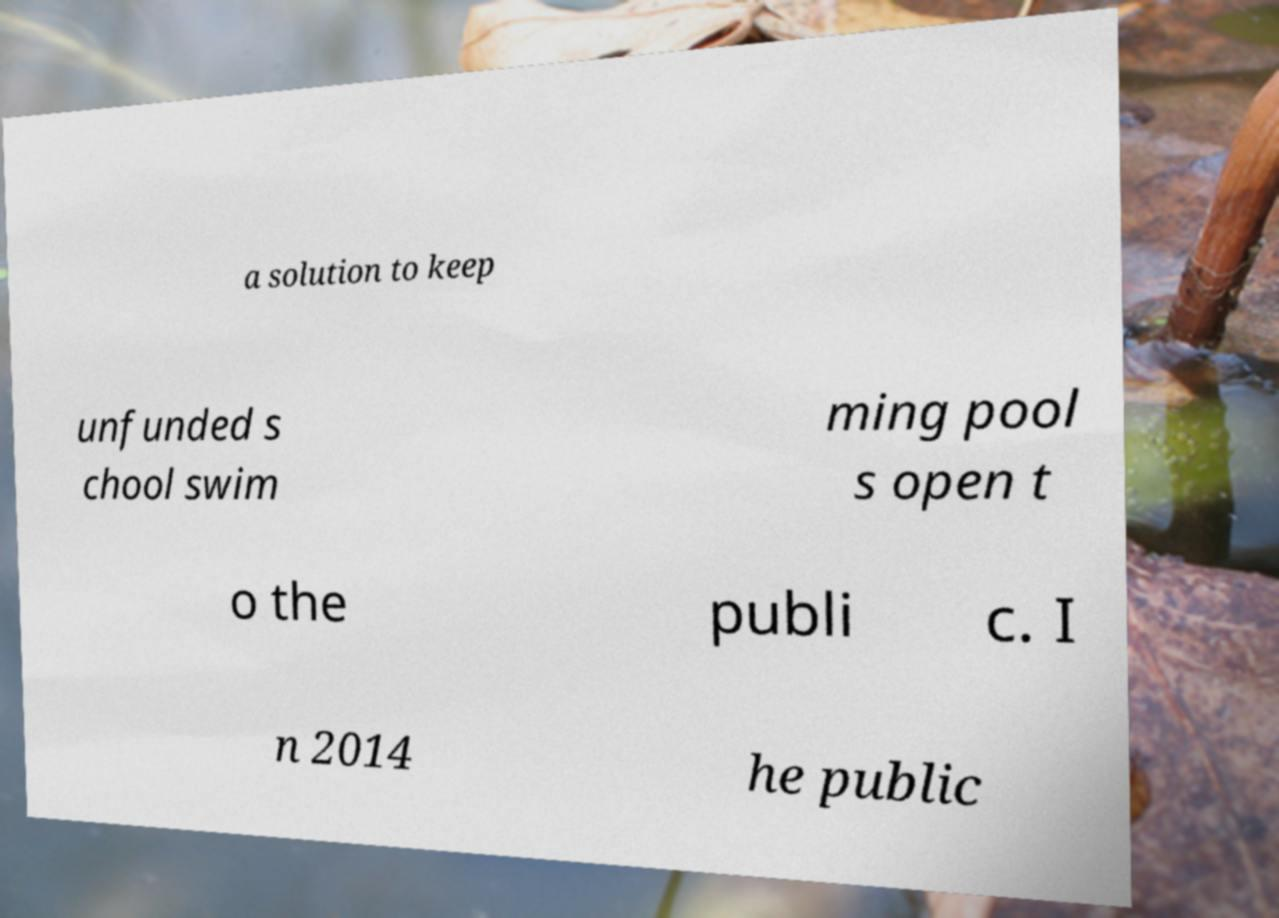Can you read and provide the text displayed in the image?This photo seems to have some interesting text. Can you extract and type it out for me? a solution to keep unfunded s chool swim ming pool s open t o the publi c. I n 2014 he public 